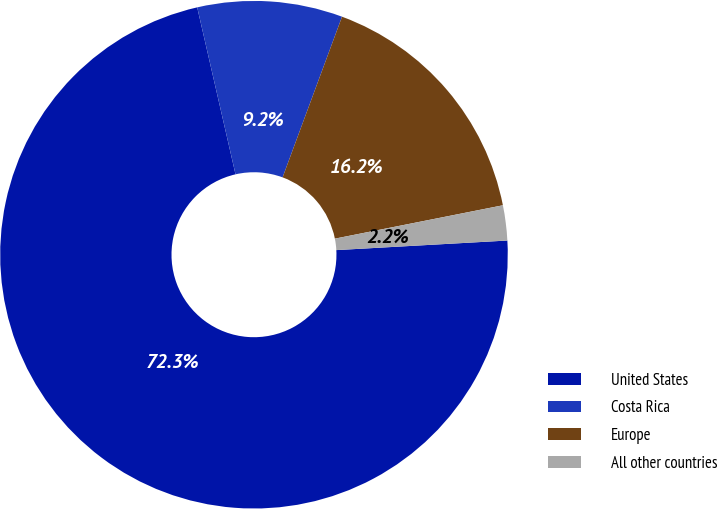Convert chart. <chart><loc_0><loc_0><loc_500><loc_500><pie_chart><fcel>United States<fcel>Costa Rica<fcel>Europe<fcel>All other countries<nl><fcel>72.3%<fcel>9.23%<fcel>16.24%<fcel>2.23%<nl></chart> 